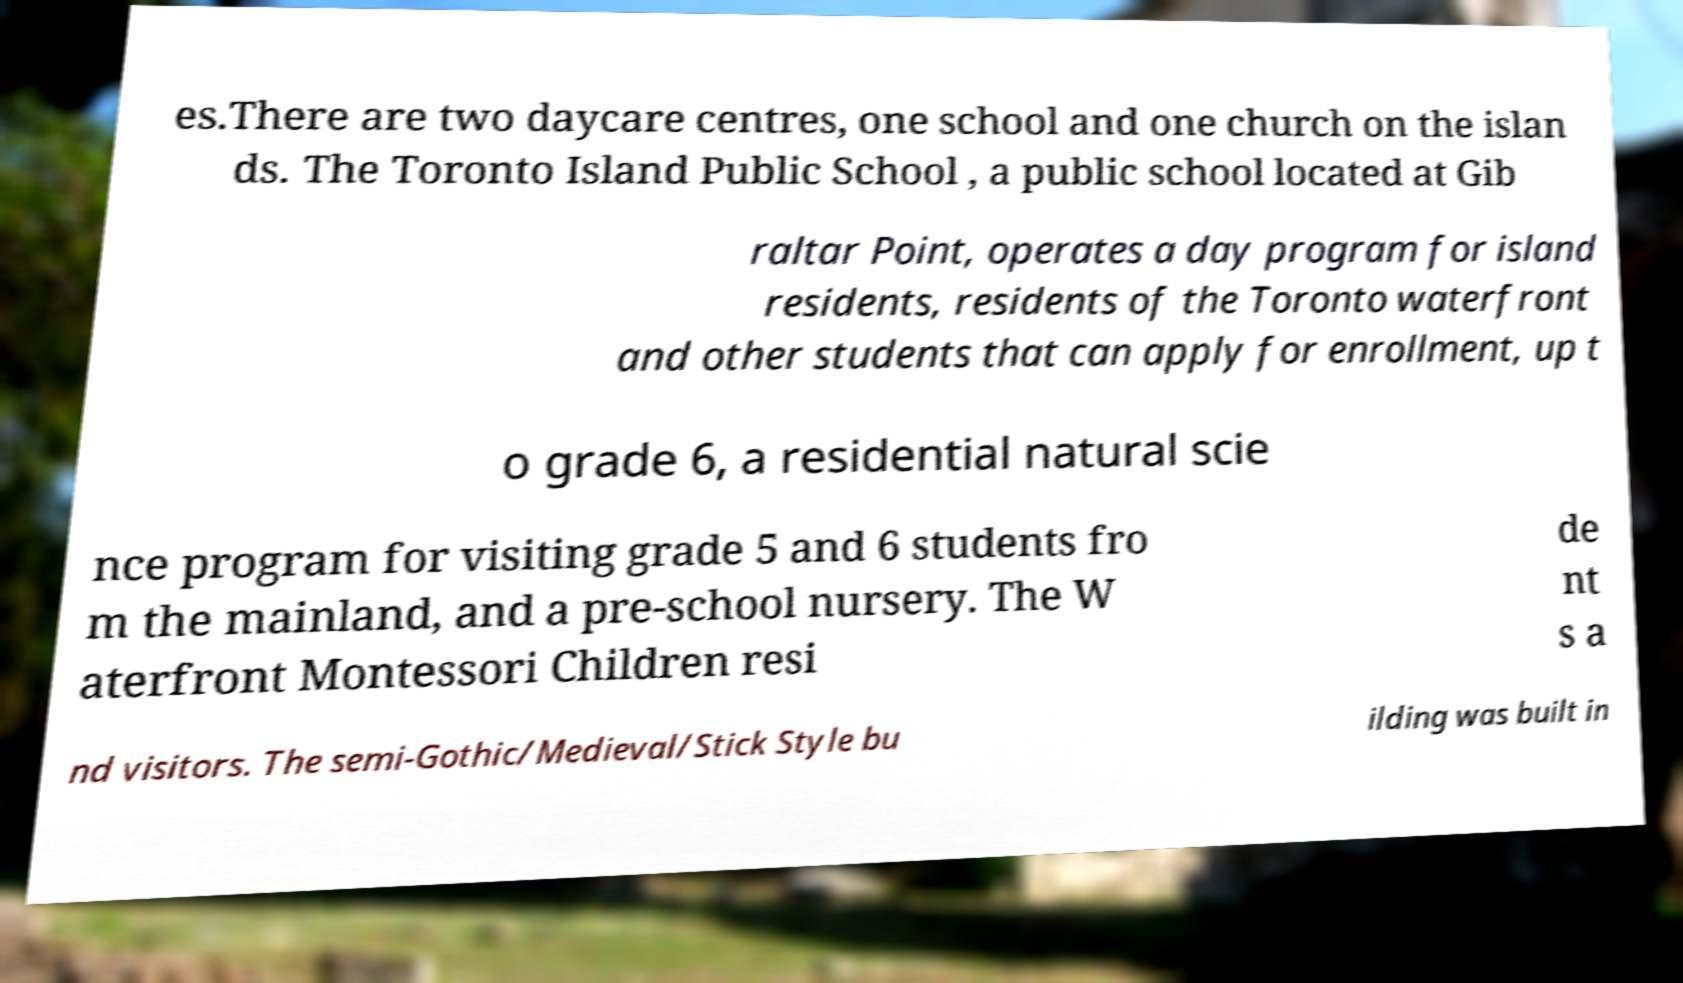Can you read and provide the text displayed in the image?This photo seems to have some interesting text. Can you extract and type it out for me? es.There are two daycare centres, one school and one church on the islan ds. The Toronto Island Public School , a public school located at Gib raltar Point, operates a day program for island residents, residents of the Toronto waterfront and other students that can apply for enrollment, up t o grade 6, a residential natural scie nce program for visiting grade 5 and 6 students fro m the mainland, and a pre-school nursery. The W aterfront Montessori Children resi de nt s a nd visitors. The semi-Gothic/Medieval/Stick Style bu ilding was built in 